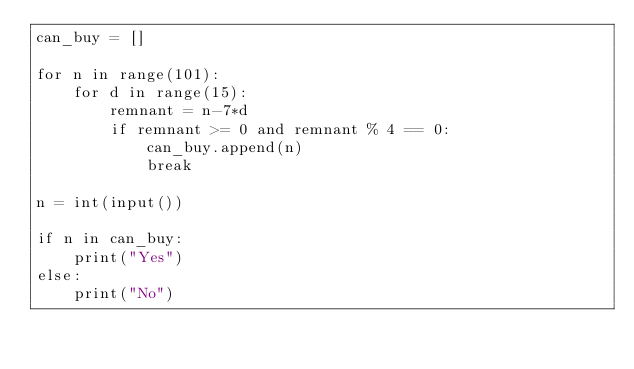<code> <loc_0><loc_0><loc_500><loc_500><_Python_>can_buy = []

for n in range(101):
    for d in range(15):
        remnant = n-7*d
        if remnant >= 0 and remnant % 4 == 0:
            can_buy.append(n)
            break

n = int(input())

if n in can_buy:
    print("Yes")
else:
    print("No")</code> 